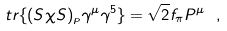<formula> <loc_0><loc_0><loc_500><loc_500>t r \{ ( S \chi S ) _ { _ { P } } \gamma ^ { \mu } \gamma ^ { 5 } \} = \sqrt { 2 } f _ { \pi } P ^ { \mu } \ ,</formula> 